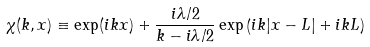Convert formula to latex. <formula><loc_0><loc_0><loc_500><loc_500>\chi ( k , x ) \equiv \exp ( i k x ) + \frac { i \lambda / 2 } { k - i \lambda / 2 } \exp \left ( i k | x - L | + i k L \right )</formula> 